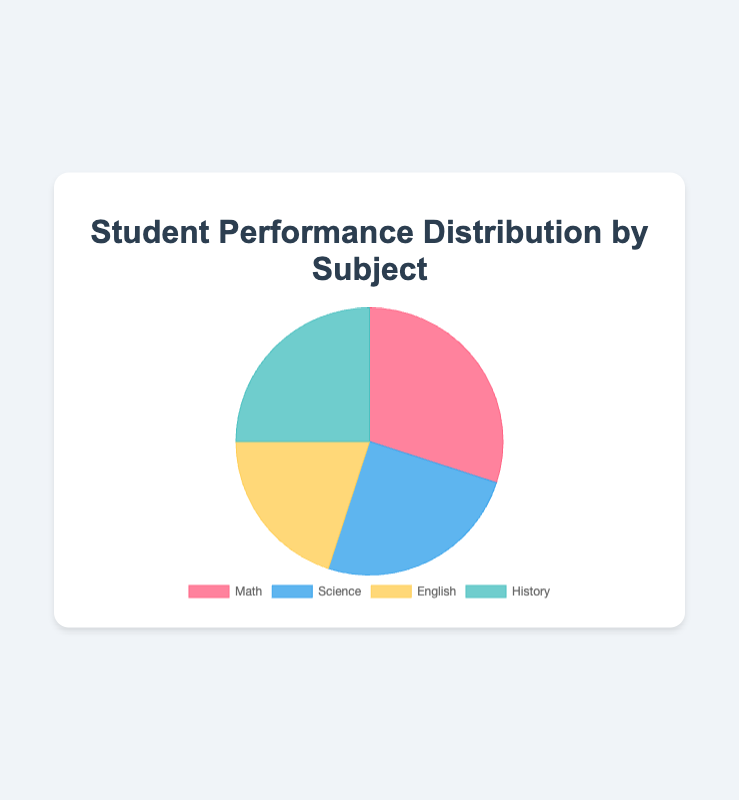What subject shows the highest performance distribution? The pie chart shows four subjects (Math, Science, English, History) with their respective performance percentages. The subject with the highest percentage is Math with 30%.
Answer: Math Which two subjects have the same performance distribution? The pie chart shows percentages for each subject. Science and History both have a performance distribution of 25%.
Answer: Science and History What's the combined performance distribution of Science and English? According to the chart, Science has 25% and English has 20%. Adding these together results in 25% + 20% = 45%.
Answer: 45% How much greater is Math's performance distribution compared to English's? The chart shows Math at 30% and English at 20%. The difference between them is 30% - 20% = 10%.
Answer: 10% What's the average performance distribution across all subjects? The total distribution percentage is the sum of all subjects: 30% (Math) + 25% (Science) + 20% (English) + 25% (History) = 100%. The average is thus 100% / 4 = 25%.
Answer: 25% If you add the performance distributions of Science and History, do they exceed Math's performance? Science and History both have 25%. Their combined percentage is 25% + 25% = 50%, which exceeds Math's 30%.
Answer: Yes Which subject has the smallest performance distribution, and what is its percentage? The pie chart shows that English has the smallest percentage, which is 20%.
Answer: English, 20% What is the total difference in performance distribution between Math and the sum of English and History? Math has 30%, English has 20%, and History has 25%. The sum of English and History is 20% + 25% = 45%. The difference between 45% and Math's 30% is 45% - 30% = 15%.
Answer: 15% Which color represents the subject with the highest performance distribution? The chart uses different colors for each subject. Math, which has the highest percentage at 30%, is represented by the color red.
Answer: Red 